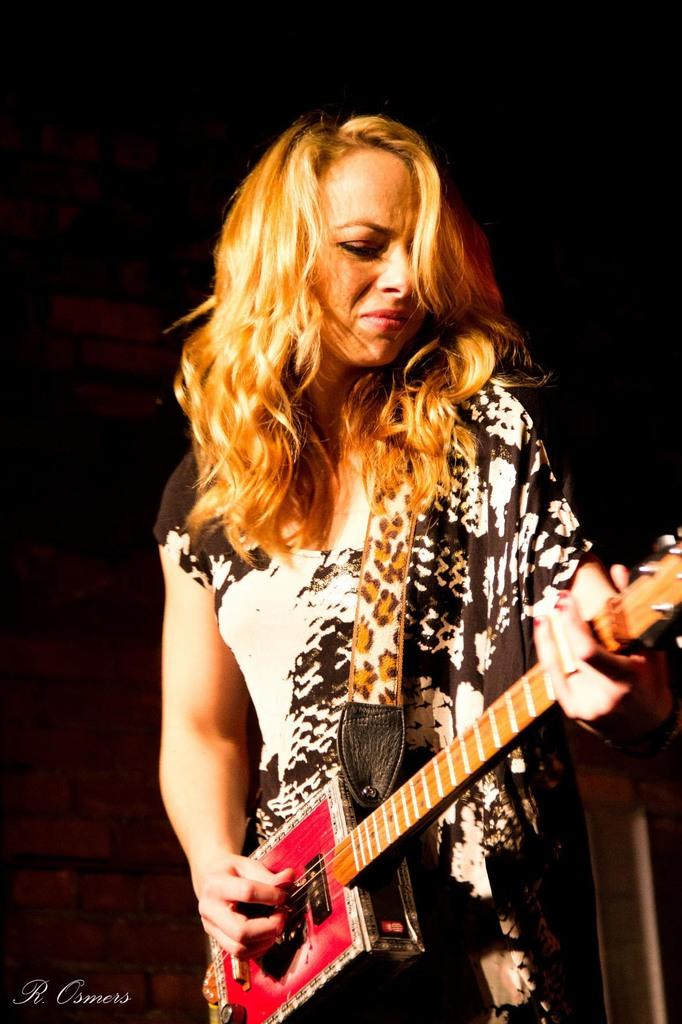What is the person in the image doing? The person is standing in the image and holding a guitar. What object is the person holding in the image? The person is holding a guitar. What can be seen in the background of the image? There is a wall visible in the background of the image. What type of sack is the person carrying in the image? There is no sack present in the image; the person is holding a guitar. What season is depicted in the image, considering the absence of winter clothing? The image does not provide any information about the season, as there is no reference to winter clothing or any other seasonal indicators. 